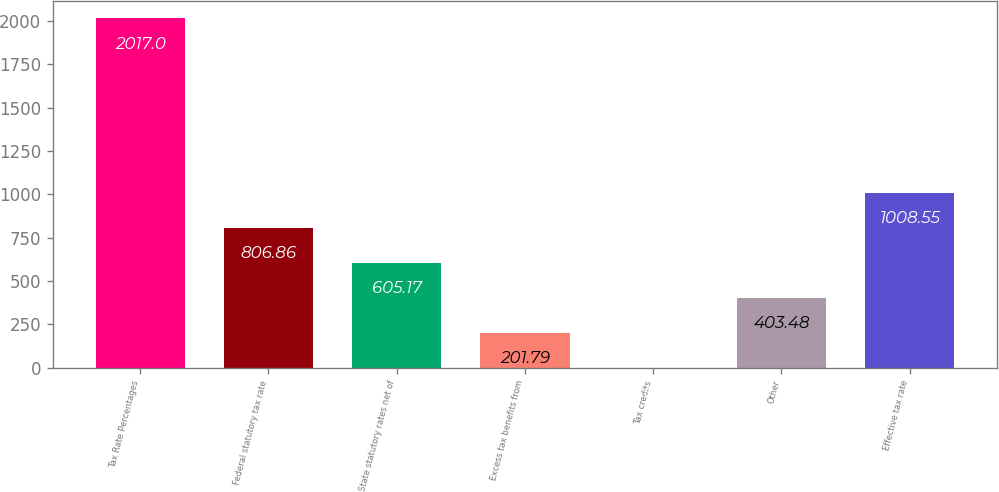Convert chart to OTSL. <chart><loc_0><loc_0><loc_500><loc_500><bar_chart><fcel>Tax Rate Percentages<fcel>Federal statutory tax rate<fcel>State statutory rates net of<fcel>Excess tax benefits from<fcel>Tax credits<fcel>Other<fcel>Effective tax rate<nl><fcel>2017<fcel>806.86<fcel>605.17<fcel>201.79<fcel>0.1<fcel>403.48<fcel>1008.55<nl></chart> 